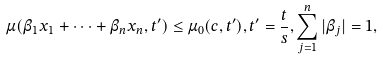Convert formula to latex. <formula><loc_0><loc_0><loc_500><loc_500>\mu ( \beta _ { 1 } x _ { 1 } + \dots + \beta _ { n } x _ { n } , t ^ { \prime } ) \leq \mu _ { 0 } ( c , t ^ { \prime } ) , t ^ { \prime } = \frac { t } { s } , \sum _ { j = 1 } ^ { n } | \beta _ { j } | = 1 ,</formula> 